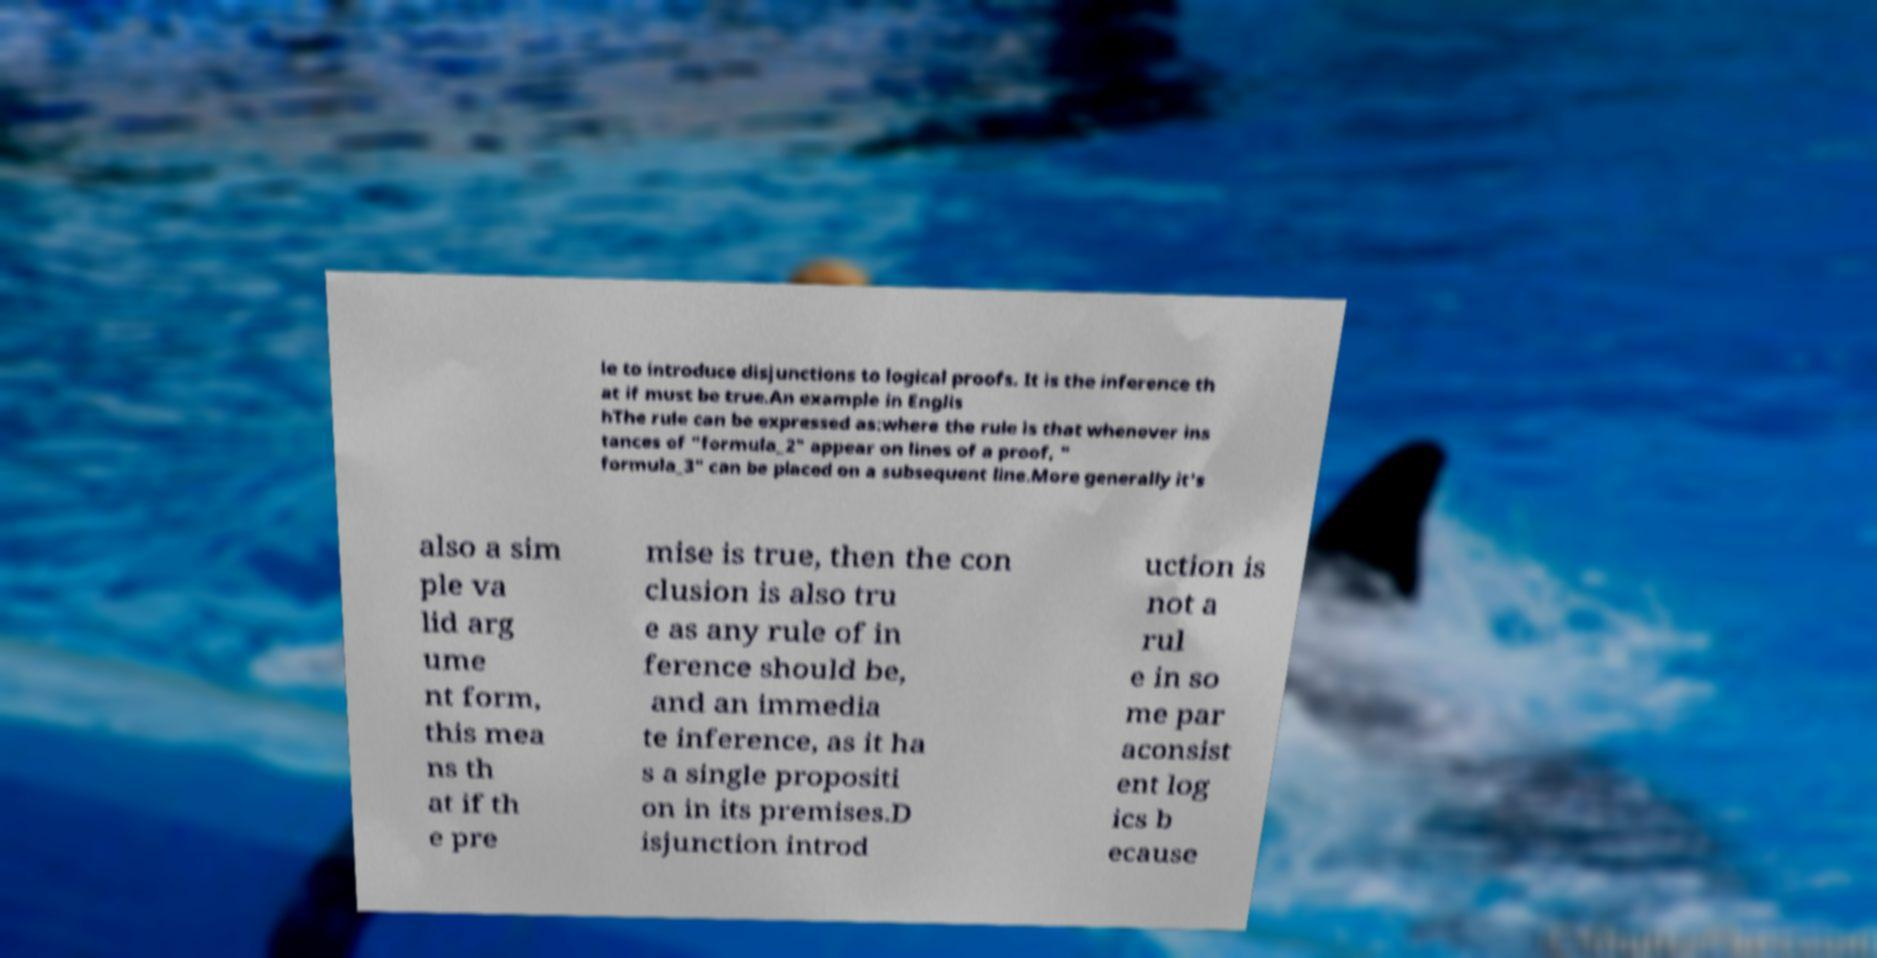There's text embedded in this image that I need extracted. Can you transcribe it verbatim? le to introduce disjunctions to logical proofs. It is the inference th at if must be true.An example in Englis hThe rule can be expressed as:where the rule is that whenever ins tances of "formula_2" appear on lines of a proof, " formula_3" can be placed on a subsequent line.More generally it's also a sim ple va lid arg ume nt form, this mea ns th at if th e pre mise is true, then the con clusion is also tru e as any rule of in ference should be, and an immedia te inference, as it ha s a single propositi on in its premises.D isjunction introd uction is not a rul e in so me par aconsist ent log ics b ecause 